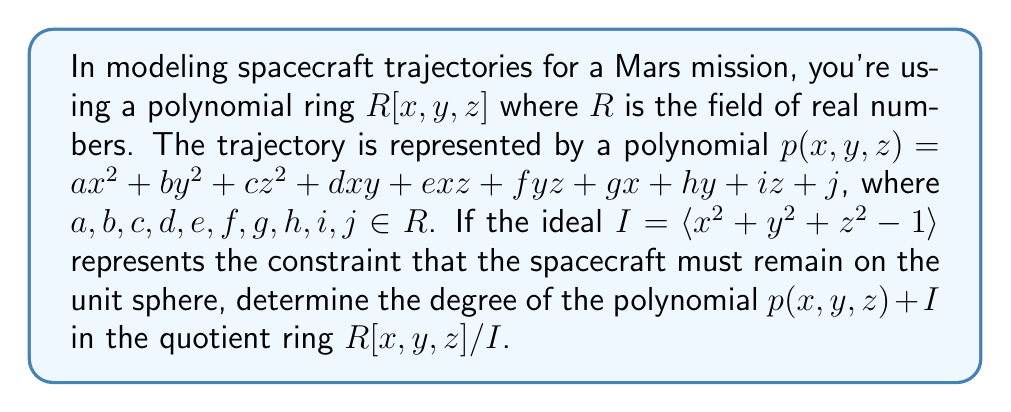Could you help me with this problem? To solve this problem, we need to understand several key concepts:

1) In the polynomial ring $R[x,y,z]$, the degree of a polynomial is the highest sum of exponents in any term.

2) The ideal $I = \langle x^2 + y^2 + z^2 - 1 \rangle$ represents the set of all polynomials that are multiples of $x^2 + y^2 + z^2 - 1$.

3) In the quotient ring $R[x,y,z]/I$, two polynomials are considered equivalent if their difference is in $I$.

4) The degree of a polynomial in $R[x,y,z]/I$ is the lowest degree among all polynomials equivalent to it in $R[x,y,z]$.

Now, let's analyze the polynomial $p(x,y,z)$:

$$p(x,y,z) = ax^2 + by^2 + cz^2 + dxy + exz + fyz + gx + hy + iz + j$$

In $R[x,y,z]$, this polynomial has degree 2.

However, in $R[x,y,z]/I$, we can use the relation $x^2 + y^2 + z^2 = 1$ (since $x^2 + y^2 + z^2 - 1 \equiv 0 \pmod{I}$) to reduce the degree of $p(x,y,z)$.

We can rewrite $p(x,y,z)$ as:

$$p(x,y,z) = a(1-y^2-z^2) + by^2 + cz^2 + dxy + exz + fyz + gx + hy + iz + j$$

Simplifying:

$$p(x,y,z) \equiv (b-a)y^2 + (c-a)z^2 + dxy + exz + fyz + gx + hy + iz + (j+a) \pmod{I}$$

This polynomial has degree 2, and we cannot reduce it further using the relation from $I$.

Therefore, the degree of $p(x,y,z) + I$ in $R[x,y,z]/I$ is 2.
Answer: The degree of the polynomial $p(x,y,z) + I$ in the quotient ring $R[x,y,z]/I$ is 2. 